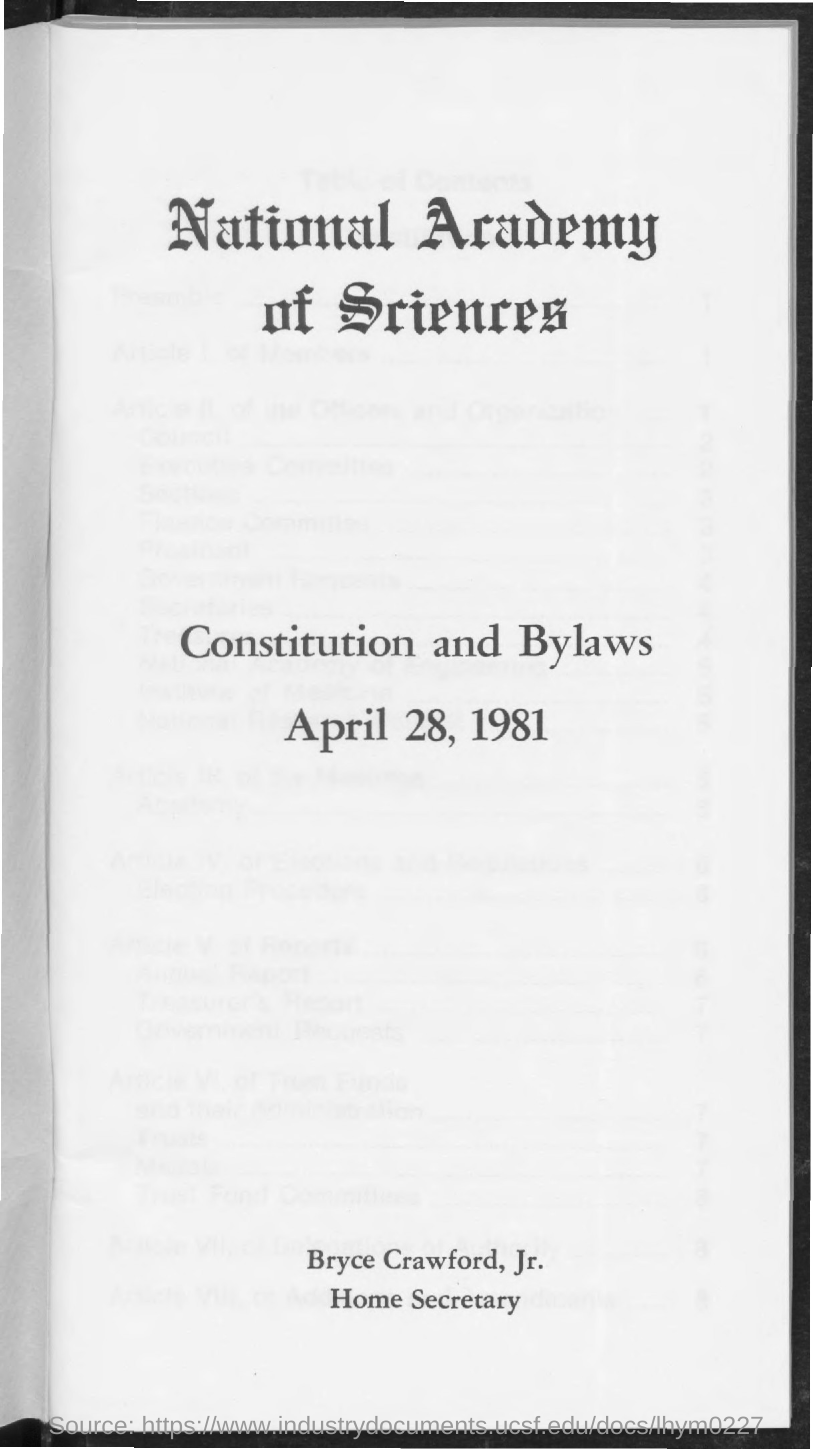What is the date mentioned ?
Keep it short and to the point. April 28, 1981. What is the designation of bryce crawford, jr ?
Give a very brief answer. Home secretary. 